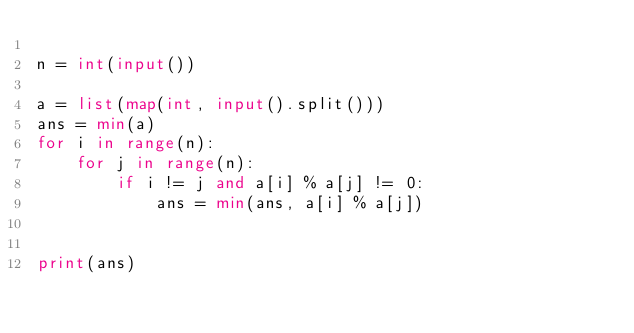Convert code to text. <code><loc_0><loc_0><loc_500><loc_500><_Python_>
n = int(input())

a = list(map(int, input().split()))
ans = min(a)
for i in range(n):
    for j in range(n):
        if i != j and a[i] % a[j] != 0:
            ans = min(ans, a[i] % a[j])
        

print(ans)
</code> 